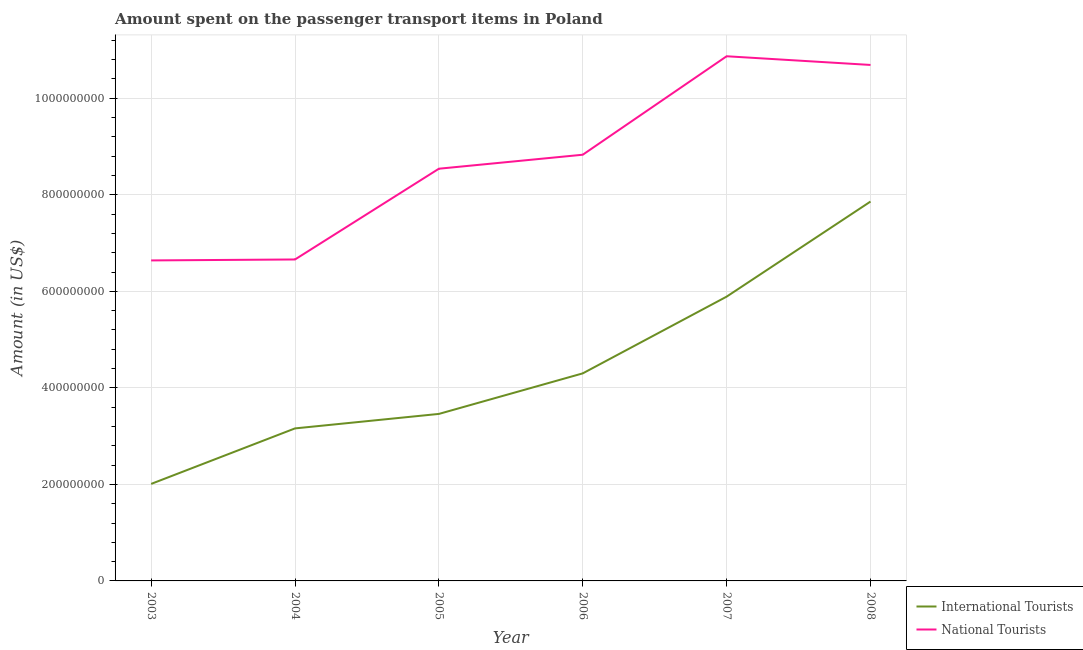Does the line corresponding to amount spent on transport items of national tourists intersect with the line corresponding to amount spent on transport items of international tourists?
Your answer should be very brief. No. What is the amount spent on transport items of national tourists in 2005?
Provide a short and direct response. 8.54e+08. Across all years, what is the maximum amount spent on transport items of national tourists?
Your answer should be compact. 1.09e+09. Across all years, what is the minimum amount spent on transport items of national tourists?
Your answer should be very brief. 6.64e+08. What is the total amount spent on transport items of international tourists in the graph?
Your answer should be compact. 2.67e+09. What is the difference between the amount spent on transport items of national tourists in 2005 and that in 2006?
Give a very brief answer. -2.90e+07. What is the difference between the amount spent on transport items of national tourists in 2006 and the amount spent on transport items of international tourists in 2005?
Keep it short and to the point. 5.37e+08. What is the average amount spent on transport items of national tourists per year?
Your answer should be very brief. 8.70e+08. In the year 2007, what is the difference between the amount spent on transport items of international tourists and amount spent on transport items of national tourists?
Keep it short and to the point. -4.98e+08. In how many years, is the amount spent on transport items of national tourists greater than 1040000000 US$?
Provide a short and direct response. 2. What is the ratio of the amount spent on transport items of national tourists in 2004 to that in 2008?
Your response must be concise. 0.62. Is the difference between the amount spent on transport items of national tourists in 2003 and 2008 greater than the difference between the amount spent on transport items of international tourists in 2003 and 2008?
Your answer should be compact. Yes. What is the difference between the highest and the second highest amount spent on transport items of international tourists?
Offer a very short reply. 1.97e+08. What is the difference between the highest and the lowest amount spent on transport items of international tourists?
Keep it short and to the point. 5.85e+08. Does the amount spent on transport items of international tourists monotonically increase over the years?
Ensure brevity in your answer.  Yes. How many lines are there?
Offer a very short reply. 2. How many years are there in the graph?
Keep it short and to the point. 6. What is the difference between two consecutive major ticks on the Y-axis?
Your response must be concise. 2.00e+08. Are the values on the major ticks of Y-axis written in scientific E-notation?
Give a very brief answer. No. Does the graph contain grids?
Offer a terse response. Yes. Where does the legend appear in the graph?
Your answer should be very brief. Bottom right. How many legend labels are there?
Your answer should be compact. 2. What is the title of the graph?
Give a very brief answer. Amount spent on the passenger transport items in Poland. What is the label or title of the X-axis?
Give a very brief answer. Year. What is the Amount (in US$) in International Tourists in 2003?
Provide a succinct answer. 2.01e+08. What is the Amount (in US$) of National Tourists in 2003?
Give a very brief answer. 6.64e+08. What is the Amount (in US$) of International Tourists in 2004?
Ensure brevity in your answer.  3.16e+08. What is the Amount (in US$) of National Tourists in 2004?
Offer a very short reply. 6.66e+08. What is the Amount (in US$) in International Tourists in 2005?
Keep it short and to the point. 3.46e+08. What is the Amount (in US$) of National Tourists in 2005?
Keep it short and to the point. 8.54e+08. What is the Amount (in US$) in International Tourists in 2006?
Give a very brief answer. 4.30e+08. What is the Amount (in US$) in National Tourists in 2006?
Keep it short and to the point. 8.83e+08. What is the Amount (in US$) in International Tourists in 2007?
Offer a terse response. 5.89e+08. What is the Amount (in US$) of National Tourists in 2007?
Your answer should be compact. 1.09e+09. What is the Amount (in US$) in International Tourists in 2008?
Your response must be concise. 7.86e+08. What is the Amount (in US$) in National Tourists in 2008?
Offer a terse response. 1.07e+09. Across all years, what is the maximum Amount (in US$) of International Tourists?
Your response must be concise. 7.86e+08. Across all years, what is the maximum Amount (in US$) of National Tourists?
Your response must be concise. 1.09e+09. Across all years, what is the minimum Amount (in US$) in International Tourists?
Give a very brief answer. 2.01e+08. Across all years, what is the minimum Amount (in US$) in National Tourists?
Your response must be concise. 6.64e+08. What is the total Amount (in US$) of International Tourists in the graph?
Your response must be concise. 2.67e+09. What is the total Amount (in US$) of National Tourists in the graph?
Your response must be concise. 5.22e+09. What is the difference between the Amount (in US$) of International Tourists in 2003 and that in 2004?
Make the answer very short. -1.15e+08. What is the difference between the Amount (in US$) of National Tourists in 2003 and that in 2004?
Your response must be concise. -2.00e+06. What is the difference between the Amount (in US$) of International Tourists in 2003 and that in 2005?
Provide a short and direct response. -1.45e+08. What is the difference between the Amount (in US$) in National Tourists in 2003 and that in 2005?
Provide a succinct answer. -1.90e+08. What is the difference between the Amount (in US$) in International Tourists in 2003 and that in 2006?
Your response must be concise. -2.29e+08. What is the difference between the Amount (in US$) in National Tourists in 2003 and that in 2006?
Give a very brief answer. -2.19e+08. What is the difference between the Amount (in US$) of International Tourists in 2003 and that in 2007?
Ensure brevity in your answer.  -3.88e+08. What is the difference between the Amount (in US$) in National Tourists in 2003 and that in 2007?
Make the answer very short. -4.23e+08. What is the difference between the Amount (in US$) of International Tourists in 2003 and that in 2008?
Your answer should be very brief. -5.85e+08. What is the difference between the Amount (in US$) of National Tourists in 2003 and that in 2008?
Keep it short and to the point. -4.05e+08. What is the difference between the Amount (in US$) of International Tourists in 2004 and that in 2005?
Provide a succinct answer. -3.00e+07. What is the difference between the Amount (in US$) in National Tourists in 2004 and that in 2005?
Your answer should be compact. -1.88e+08. What is the difference between the Amount (in US$) of International Tourists in 2004 and that in 2006?
Provide a short and direct response. -1.14e+08. What is the difference between the Amount (in US$) of National Tourists in 2004 and that in 2006?
Give a very brief answer. -2.17e+08. What is the difference between the Amount (in US$) of International Tourists in 2004 and that in 2007?
Offer a terse response. -2.73e+08. What is the difference between the Amount (in US$) of National Tourists in 2004 and that in 2007?
Keep it short and to the point. -4.21e+08. What is the difference between the Amount (in US$) in International Tourists in 2004 and that in 2008?
Your answer should be compact. -4.70e+08. What is the difference between the Amount (in US$) of National Tourists in 2004 and that in 2008?
Offer a terse response. -4.03e+08. What is the difference between the Amount (in US$) of International Tourists in 2005 and that in 2006?
Your response must be concise. -8.40e+07. What is the difference between the Amount (in US$) in National Tourists in 2005 and that in 2006?
Ensure brevity in your answer.  -2.90e+07. What is the difference between the Amount (in US$) of International Tourists in 2005 and that in 2007?
Your response must be concise. -2.43e+08. What is the difference between the Amount (in US$) of National Tourists in 2005 and that in 2007?
Provide a short and direct response. -2.33e+08. What is the difference between the Amount (in US$) of International Tourists in 2005 and that in 2008?
Your answer should be very brief. -4.40e+08. What is the difference between the Amount (in US$) of National Tourists in 2005 and that in 2008?
Your answer should be compact. -2.15e+08. What is the difference between the Amount (in US$) of International Tourists in 2006 and that in 2007?
Provide a short and direct response. -1.59e+08. What is the difference between the Amount (in US$) of National Tourists in 2006 and that in 2007?
Your answer should be very brief. -2.04e+08. What is the difference between the Amount (in US$) of International Tourists in 2006 and that in 2008?
Offer a terse response. -3.56e+08. What is the difference between the Amount (in US$) in National Tourists in 2006 and that in 2008?
Provide a short and direct response. -1.86e+08. What is the difference between the Amount (in US$) in International Tourists in 2007 and that in 2008?
Ensure brevity in your answer.  -1.97e+08. What is the difference between the Amount (in US$) in National Tourists in 2007 and that in 2008?
Your answer should be very brief. 1.80e+07. What is the difference between the Amount (in US$) in International Tourists in 2003 and the Amount (in US$) in National Tourists in 2004?
Keep it short and to the point. -4.65e+08. What is the difference between the Amount (in US$) of International Tourists in 2003 and the Amount (in US$) of National Tourists in 2005?
Make the answer very short. -6.53e+08. What is the difference between the Amount (in US$) in International Tourists in 2003 and the Amount (in US$) in National Tourists in 2006?
Provide a short and direct response. -6.82e+08. What is the difference between the Amount (in US$) in International Tourists in 2003 and the Amount (in US$) in National Tourists in 2007?
Keep it short and to the point. -8.86e+08. What is the difference between the Amount (in US$) of International Tourists in 2003 and the Amount (in US$) of National Tourists in 2008?
Your response must be concise. -8.68e+08. What is the difference between the Amount (in US$) in International Tourists in 2004 and the Amount (in US$) in National Tourists in 2005?
Give a very brief answer. -5.38e+08. What is the difference between the Amount (in US$) of International Tourists in 2004 and the Amount (in US$) of National Tourists in 2006?
Provide a short and direct response. -5.67e+08. What is the difference between the Amount (in US$) of International Tourists in 2004 and the Amount (in US$) of National Tourists in 2007?
Provide a short and direct response. -7.71e+08. What is the difference between the Amount (in US$) in International Tourists in 2004 and the Amount (in US$) in National Tourists in 2008?
Your answer should be very brief. -7.53e+08. What is the difference between the Amount (in US$) in International Tourists in 2005 and the Amount (in US$) in National Tourists in 2006?
Provide a succinct answer. -5.37e+08. What is the difference between the Amount (in US$) in International Tourists in 2005 and the Amount (in US$) in National Tourists in 2007?
Give a very brief answer. -7.41e+08. What is the difference between the Amount (in US$) in International Tourists in 2005 and the Amount (in US$) in National Tourists in 2008?
Your answer should be very brief. -7.23e+08. What is the difference between the Amount (in US$) in International Tourists in 2006 and the Amount (in US$) in National Tourists in 2007?
Offer a very short reply. -6.57e+08. What is the difference between the Amount (in US$) of International Tourists in 2006 and the Amount (in US$) of National Tourists in 2008?
Give a very brief answer. -6.39e+08. What is the difference between the Amount (in US$) of International Tourists in 2007 and the Amount (in US$) of National Tourists in 2008?
Your answer should be very brief. -4.80e+08. What is the average Amount (in US$) in International Tourists per year?
Your response must be concise. 4.45e+08. What is the average Amount (in US$) in National Tourists per year?
Ensure brevity in your answer.  8.70e+08. In the year 2003, what is the difference between the Amount (in US$) in International Tourists and Amount (in US$) in National Tourists?
Give a very brief answer. -4.63e+08. In the year 2004, what is the difference between the Amount (in US$) in International Tourists and Amount (in US$) in National Tourists?
Provide a short and direct response. -3.50e+08. In the year 2005, what is the difference between the Amount (in US$) in International Tourists and Amount (in US$) in National Tourists?
Give a very brief answer. -5.08e+08. In the year 2006, what is the difference between the Amount (in US$) in International Tourists and Amount (in US$) in National Tourists?
Offer a terse response. -4.53e+08. In the year 2007, what is the difference between the Amount (in US$) of International Tourists and Amount (in US$) of National Tourists?
Your response must be concise. -4.98e+08. In the year 2008, what is the difference between the Amount (in US$) in International Tourists and Amount (in US$) in National Tourists?
Your answer should be compact. -2.83e+08. What is the ratio of the Amount (in US$) in International Tourists in 2003 to that in 2004?
Your response must be concise. 0.64. What is the ratio of the Amount (in US$) of National Tourists in 2003 to that in 2004?
Your answer should be very brief. 1. What is the ratio of the Amount (in US$) of International Tourists in 2003 to that in 2005?
Give a very brief answer. 0.58. What is the ratio of the Amount (in US$) in National Tourists in 2003 to that in 2005?
Offer a very short reply. 0.78. What is the ratio of the Amount (in US$) in International Tourists in 2003 to that in 2006?
Keep it short and to the point. 0.47. What is the ratio of the Amount (in US$) in National Tourists in 2003 to that in 2006?
Your answer should be compact. 0.75. What is the ratio of the Amount (in US$) of International Tourists in 2003 to that in 2007?
Your answer should be very brief. 0.34. What is the ratio of the Amount (in US$) in National Tourists in 2003 to that in 2007?
Give a very brief answer. 0.61. What is the ratio of the Amount (in US$) in International Tourists in 2003 to that in 2008?
Provide a succinct answer. 0.26. What is the ratio of the Amount (in US$) of National Tourists in 2003 to that in 2008?
Your answer should be very brief. 0.62. What is the ratio of the Amount (in US$) in International Tourists in 2004 to that in 2005?
Provide a succinct answer. 0.91. What is the ratio of the Amount (in US$) of National Tourists in 2004 to that in 2005?
Provide a short and direct response. 0.78. What is the ratio of the Amount (in US$) in International Tourists in 2004 to that in 2006?
Your answer should be very brief. 0.73. What is the ratio of the Amount (in US$) in National Tourists in 2004 to that in 2006?
Your answer should be very brief. 0.75. What is the ratio of the Amount (in US$) of International Tourists in 2004 to that in 2007?
Offer a terse response. 0.54. What is the ratio of the Amount (in US$) of National Tourists in 2004 to that in 2007?
Make the answer very short. 0.61. What is the ratio of the Amount (in US$) in International Tourists in 2004 to that in 2008?
Your response must be concise. 0.4. What is the ratio of the Amount (in US$) of National Tourists in 2004 to that in 2008?
Give a very brief answer. 0.62. What is the ratio of the Amount (in US$) of International Tourists in 2005 to that in 2006?
Offer a very short reply. 0.8. What is the ratio of the Amount (in US$) of National Tourists in 2005 to that in 2006?
Provide a short and direct response. 0.97. What is the ratio of the Amount (in US$) in International Tourists in 2005 to that in 2007?
Provide a short and direct response. 0.59. What is the ratio of the Amount (in US$) in National Tourists in 2005 to that in 2007?
Offer a very short reply. 0.79. What is the ratio of the Amount (in US$) of International Tourists in 2005 to that in 2008?
Give a very brief answer. 0.44. What is the ratio of the Amount (in US$) in National Tourists in 2005 to that in 2008?
Make the answer very short. 0.8. What is the ratio of the Amount (in US$) in International Tourists in 2006 to that in 2007?
Provide a short and direct response. 0.73. What is the ratio of the Amount (in US$) of National Tourists in 2006 to that in 2007?
Offer a terse response. 0.81. What is the ratio of the Amount (in US$) in International Tourists in 2006 to that in 2008?
Ensure brevity in your answer.  0.55. What is the ratio of the Amount (in US$) in National Tourists in 2006 to that in 2008?
Your response must be concise. 0.83. What is the ratio of the Amount (in US$) of International Tourists in 2007 to that in 2008?
Your response must be concise. 0.75. What is the ratio of the Amount (in US$) of National Tourists in 2007 to that in 2008?
Ensure brevity in your answer.  1.02. What is the difference between the highest and the second highest Amount (in US$) of International Tourists?
Provide a short and direct response. 1.97e+08. What is the difference between the highest and the second highest Amount (in US$) in National Tourists?
Provide a succinct answer. 1.80e+07. What is the difference between the highest and the lowest Amount (in US$) in International Tourists?
Provide a short and direct response. 5.85e+08. What is the difference between the highest and the lowest Amount (in US$) in National Tourists?
Your answer should be very brief. 4.23e+08. 